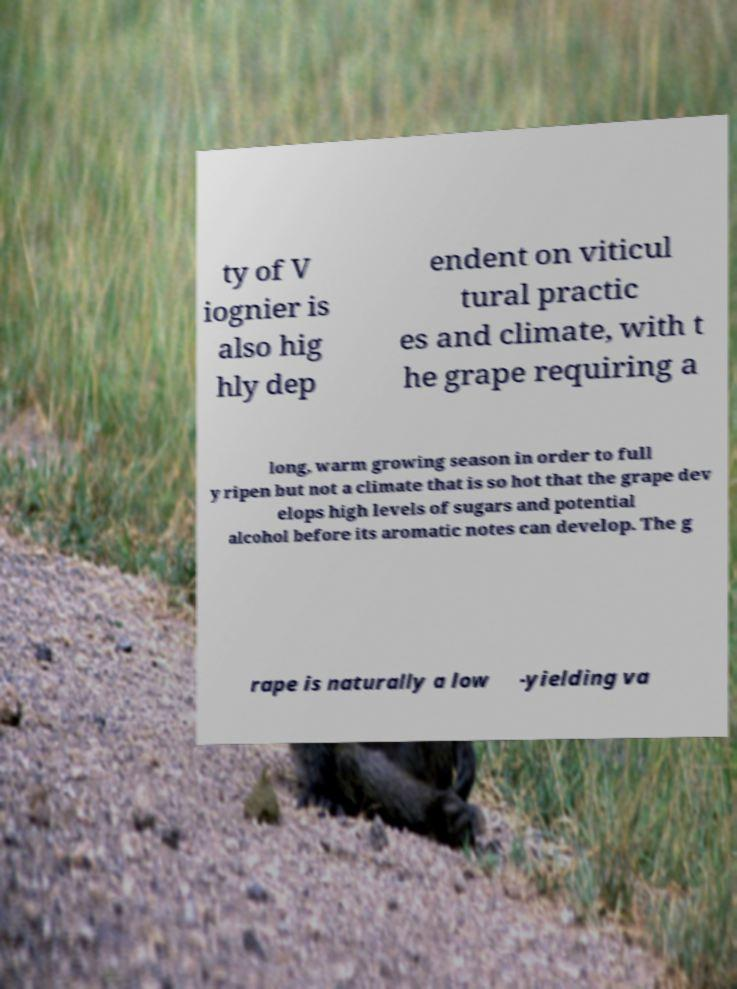Could you assist in decoding the text presented in this image and type it out clearly? ty of V iognier is also hig hly dep endent on viticul tural practic es and climate, with t he grape requiring a long, warm growing season in order to full y ripen but not a climate that is so hot that the grape dev elops high levels of sugars and potential alcohol before its aromatic notes can develop. The g rape is naturally a low -yielding va 